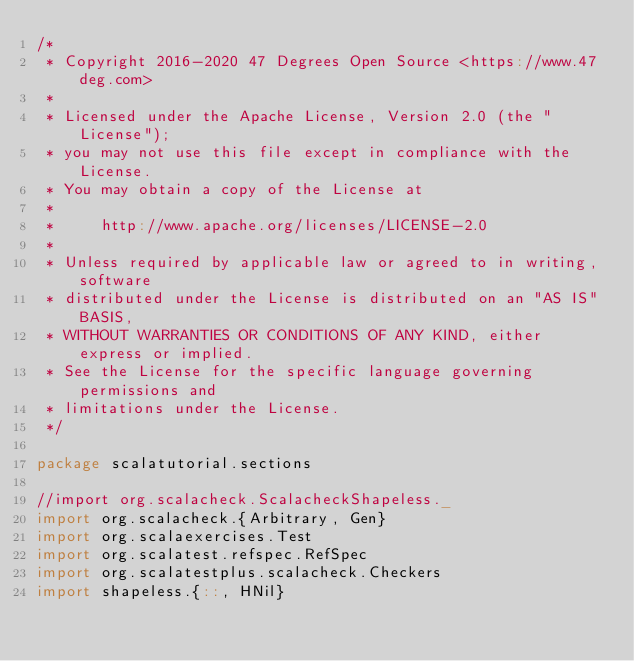<code> <loc_0><loc_0><loc_500><loc_500><_Scala_>/*
 * Copyright 2016-2020 47 Degrees Open Source <https://www.47deg.com>
 *
 * Licensed under the Apache License, Version 2.0 (the "License");
 * you may not use this file except in compliance with the License.
 * You may obtain a copy of the License at
 *
 *     http://www.apache.org/licenses/LICENSE-2.0
 *
 * Unless required by applicable law or agreed to in writing, software
 * distributed under the License is distributed on an "AS IS" BASIS,
 * WITHOUT WARRANTIES OR CONDITIONS OF ANY KIND, either express or implied.
 * See the License for the specific language governing permissions and
 * limitations under the License.
 */

package scalatutorial.sections

//import org.scalacheck.ScalacheckShapeless._
import org.scalacheck.{Arbitrary, Gen}
import org.scalaexercises.Test
import org.scalatest.refspec.RefSpec
import org.scalatestplus.scalacheck.Checkers
import shapeless.{::, HNil}
</code> 